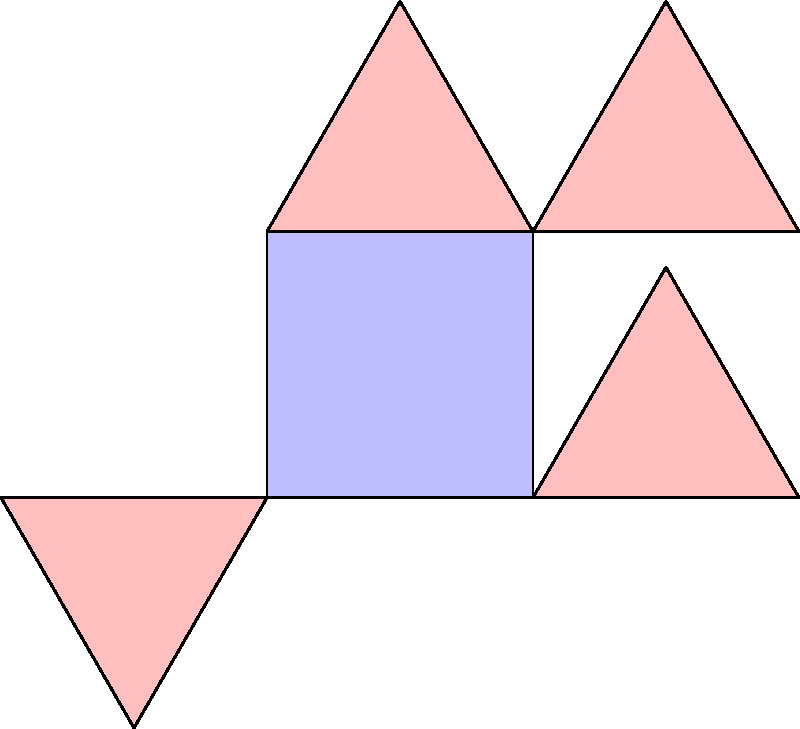As a museum curator, you've noticed an interesting floor tile pattern in one of the exhibition rooms. The pattern consists of a square tile with four equilateral triangles arranged around it, as shown in the diagram. What is the order of the symmetry group for this floor tile pattern? To determine the order of the symmetry group, we need to identify all the symmetry operations that leave the pattern unchanged:

1. Rotational symmetries:
   - 360° (identity)
   - 90° clockwise
   - 180°
   - 270° clockwise (90° counterclockwise)

2. Reflection symmetries:
   - Vertical line through the center
   - Horizontal line through the center
   - Diagonal line from top-left to bottom-right
   - Diagonal line from top-right to bottom-left

In total, we have identified 8 symmetry operations:
4 rotations + 4 reflections = 8

Each of these symmetry operations, when applied to the pattern, leaves it unchanged. These operations form a group under composition, known as the symmetry group of the pattern.

The order of a group is the number of elements in the group. In this case, the order of the symmetry group is 8.

This symmetry group is isomorphic to the dihedral group $D_4$, which is the symmetry group of a square.
Answer: 8 